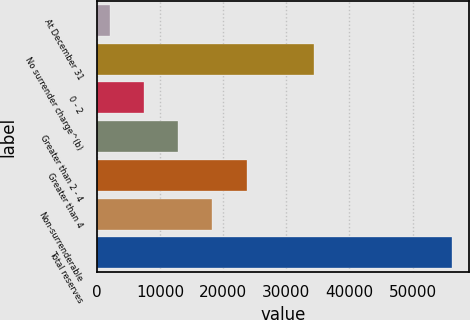Convert chart to OTSL. <chart><loc_0><loc_0><loc_500><loc_500><bar_chart><fcel>At December 31<fcel>No surrender charge^(b)<fcel>0 - 2<fcel>Greater than 2 - 4<fcel>Greater than 4<fcel>Non-surrenderable<fcel>Total reserves<nl><fcel>2014<fcel>34396<fcel>7431.8<fcel>12849.6<fcel>23685.2<fcel>18267.4<fcel>56192<nl></chart> 